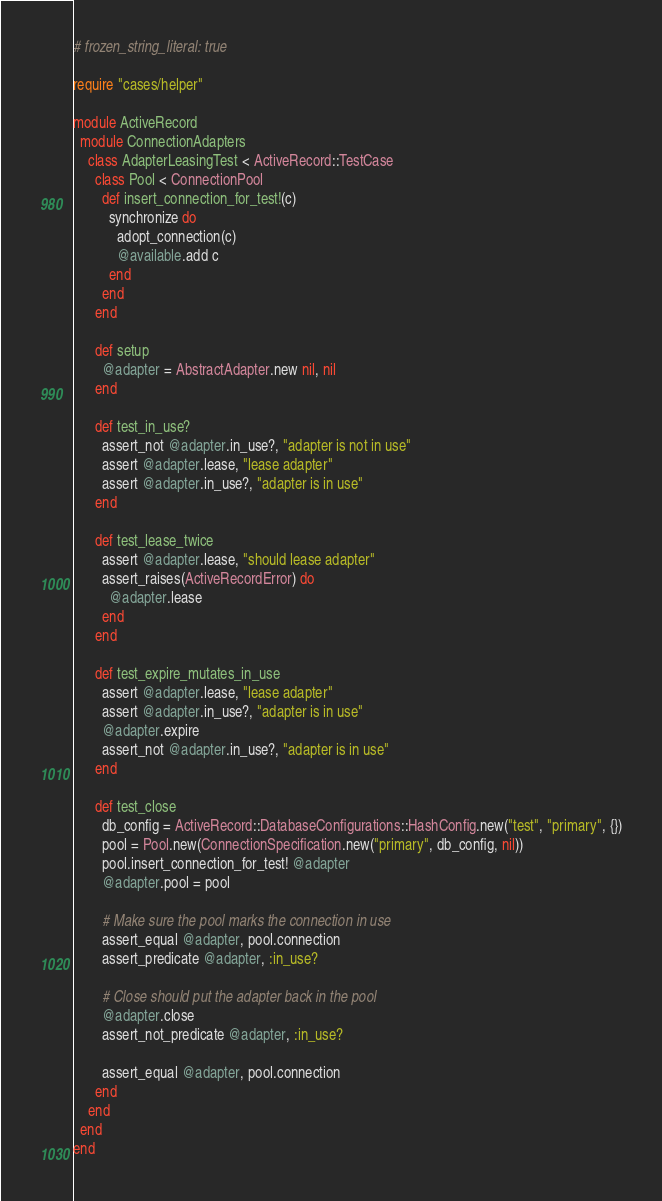<code> <loc_0><loc_0><loc_500><loc_500><_Ruby_># frozen_string_literal: true

require "cases/helper"

module ActiveRecord
  module ConnectionAdapters
    class AdapterLeasingTest < ActiveRecord::TestCase
      class Pool < ConnectionPool
        def insert_connection_for_test!(c)
          synchronize do
            adopt_connection(c)
            @available.add c
          end
        end
      end

      def setup
        @adapter = AbstractAdapter.new nil, nil
      end

      def test_in_use?
        assert_not @adapter.in_use?, "adapter is not in use"
        assert @adapter.lease, "lease adapter"
        assert @adapter.in_use?, "adapter is in use"
      end

      def test_lease_twice
        assert @adapter.lease, "should lease adapter"
        assert_raises(ActiveRecordError) do
          @adapter.lease
        end
      end

      def test_expire_mutates_in_use
        assert @adapter.lease, "lease adapter"
        assert @adapter.in_use?, "adapter is in use"
        @adapter.expire
        assert_not @adapter.in_use?, "adapter is in use"
      end

      def test_close
        db_config = ActiveRecord::DatabaseConfigurations::HashConfig.new("test", "primary", {})
        pool = Pool.new(ConnectionSpecification.new("primary", db_config, nil))
        pool.insert_connection_for_test! @adapter
        @adapter.pool = pool

        # Make sure the pool marks the connection in use
        assert_equal @adapter, pool.connection
        assert_predicate @adapter, :in_use?

        # Close should put the adapter back in the pool
        @adapter.close
        assert_not_predicate @adapter, :in_use?

        assert_equal @adapter, pool.connection
      end
    end
  end
end
</code> 